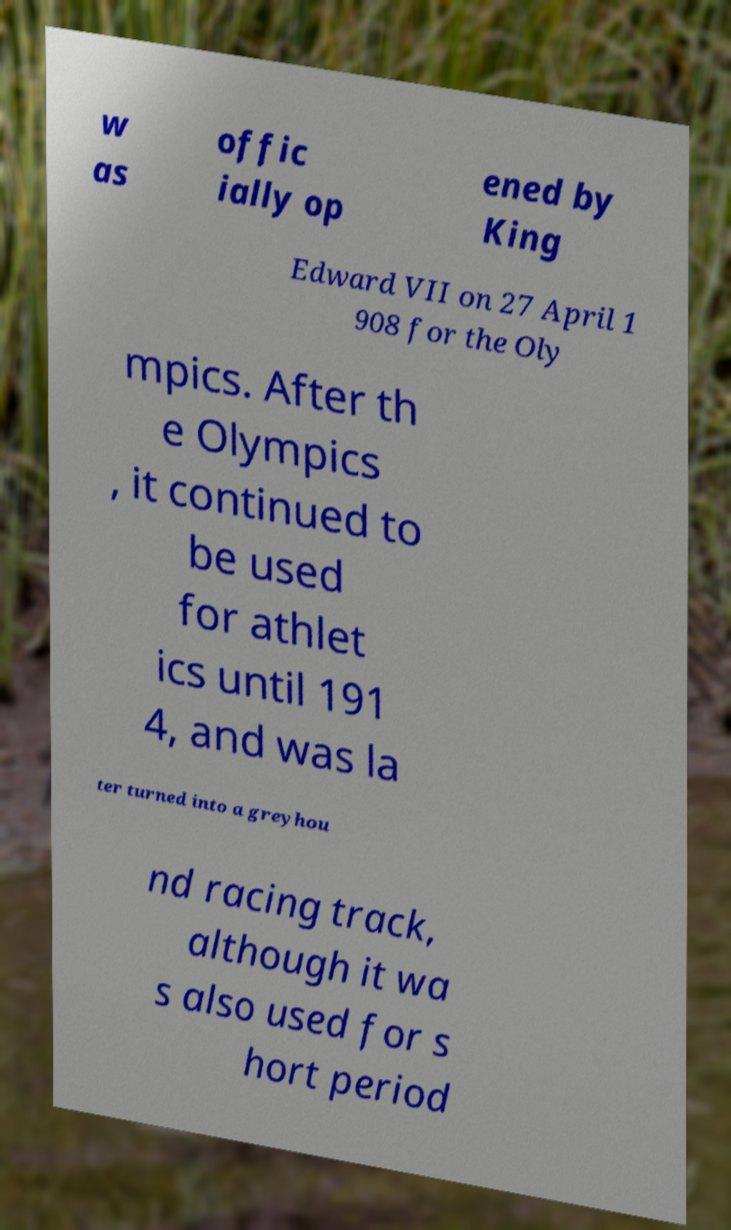What messages or text are displayed in this image? I need them in a readable, typed format. w as offic ially op ened by King Edward VII on 27 April 1 908 for the Oly mpics. After th e Olympics , it continued to be used for athlet ics until 191 4, and was la ter turned into a greyhou nd racing track, although it wa s also used for s hort period 